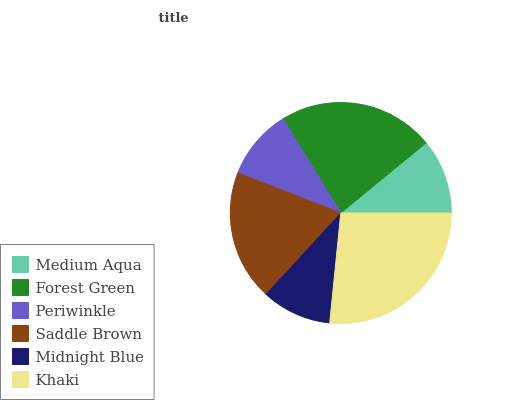Is Midnight Blue the minimum?
Answer yes or no. Yes. Is Khaki the maximum?
Answer yes or no. Yes. Is Forest Green the minimum?
Answer yes or no. No. Is Forest Green the maximum?
Answer yes or no. No. Is Forest Green greater than Medium Aqua?
Answer yes or no. Yes. Is Medium Aqua less than Forest Green?
Answer yes or no. Yes. Is Medium Aqua greater than Forest Green?
Answer yes or no. No. Is Forest Green less than Medium Aqua?
Answer yes or no. No. Is Saddle Brown the high median?
Answer yes or no. Yes. Is Medium Aqua the low median?
Answer yes or no. Yes. Is Periwinkle the high median?
Answer yes or no. No. Is Periwinkle the low median?
Answer yes or no. No. 